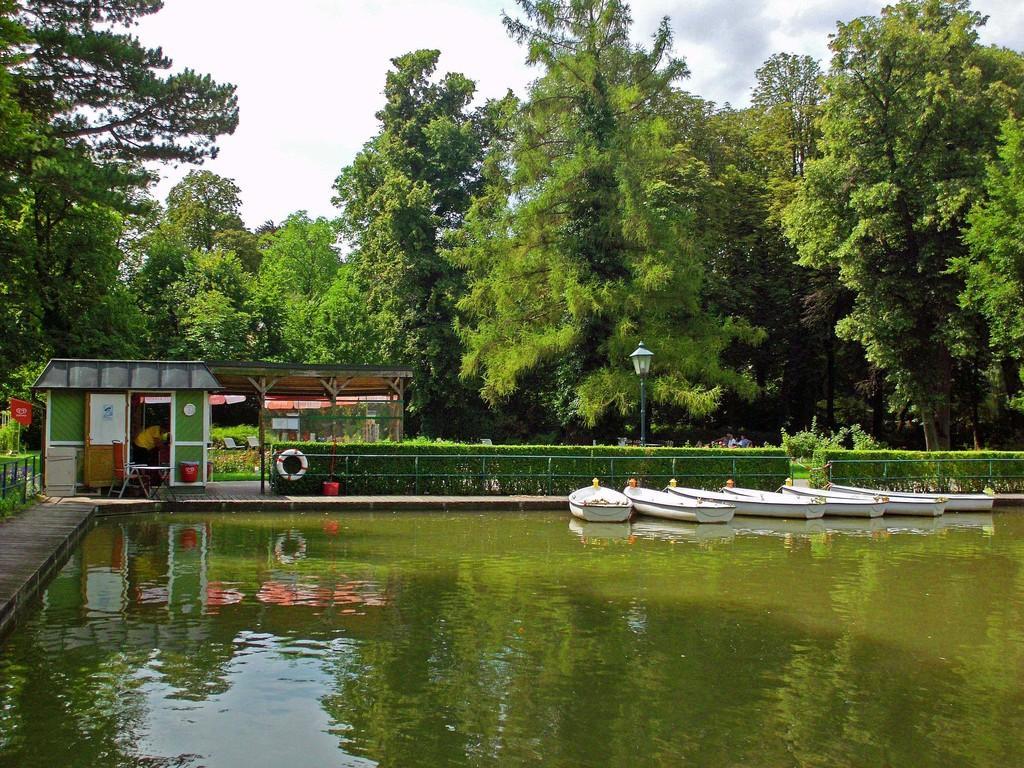Describe this image in one or two sentences. In this image we can see boats on the water, fence, plants, swimming ring on the fence, objects on the platform, person in a room, door, trees, plants and sky. 